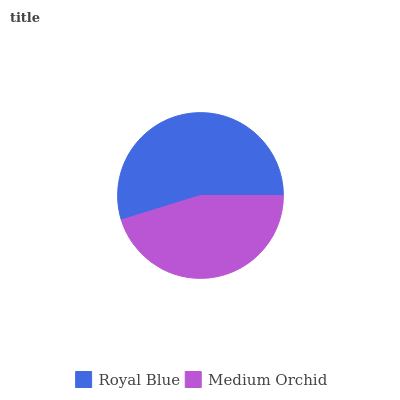Is Medium Orchid the minimum?
Answer yes or no. Yes. Is Royal Blue the maximum?
Answer yes or no. Yes. Is Medium Orchid the maximum?
Answer yes or no. No. Is Royal Blue greater than Medium Orchid?
Answer yes or no. Yes. Is Medium Orchid less than Royal Blue?
Answer yes or no. Yes. Is Medium Orchid greater than Royal Blue?
Answer yes or no. No. Is Royal Blue less than Medium Orchid?
Answer yes or no. No. Is Royal Blue the high median?
Answer yes or no. Yes. Is Medium Orchid the low median?
Answer yes or no. Yes. Is Medium Orchid the high median?
Answer yes or no. No. Is Royal Blue the low median?
Answer yes or no. No. 